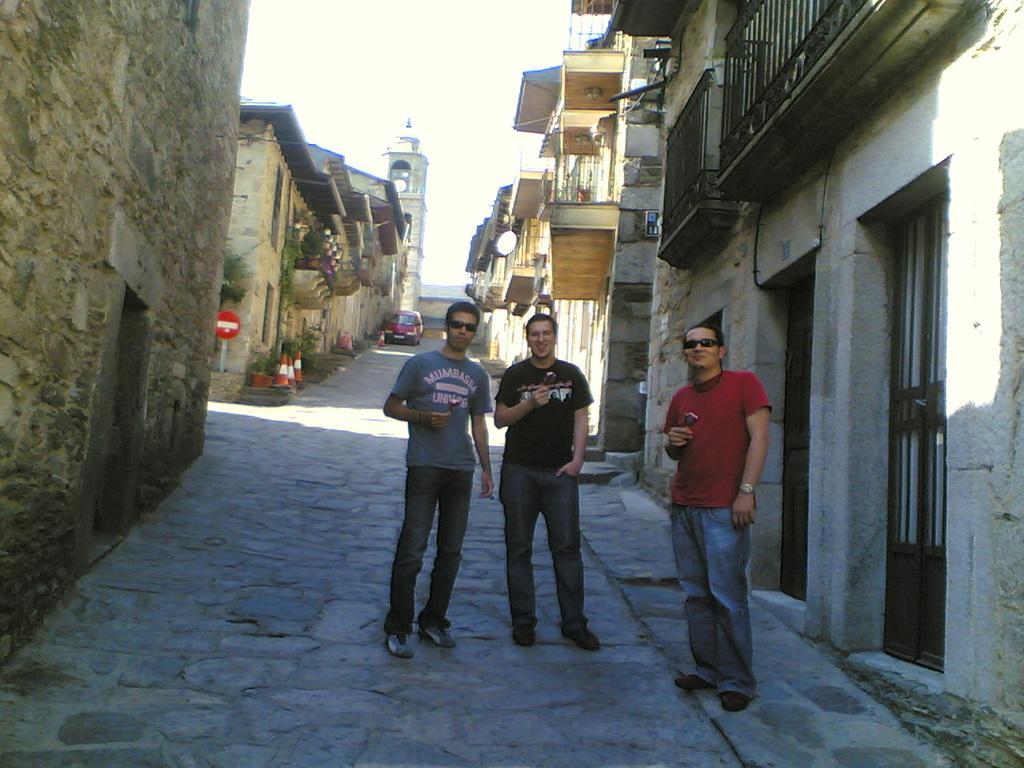Please provide a concise description of this image. In this picture there is a man who is wearing black t-shirt, jeans and shoe. Beside him there is another man who is wearing goggles, t-shirt, jeans and shoe. He is holding a ice cream. On the right there is another man who is wearing goggles, red t-shirt, watch, jeans, shoes and holding ice cream. He is standing near the doors. In the back there is a red car which is parked near to the wall. On the left I can see some traffic cones & boards near to the plants and buildings. At the top there is a sky. In the background I can see the tower and buildings. 